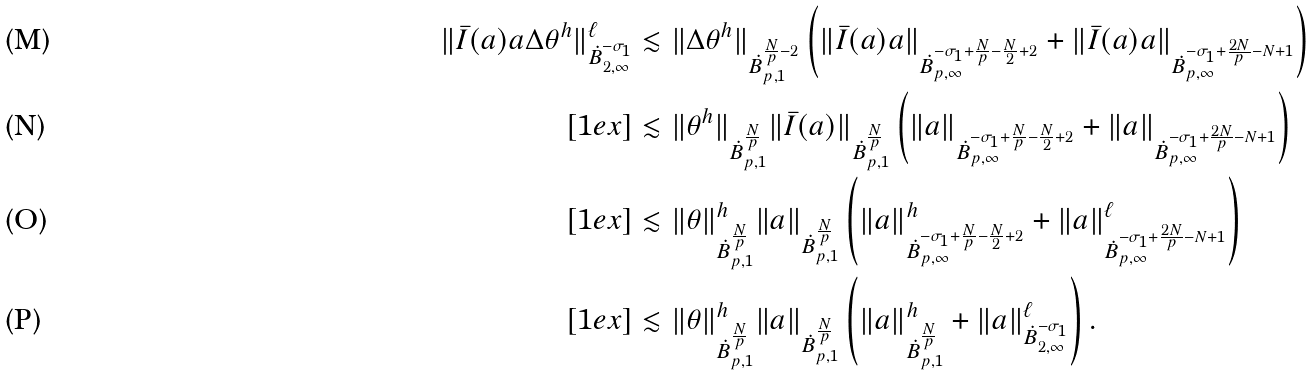<formula> <loc_0><loc_0><loc_500><loc_500>\| \bar { I } ( a ) a \Delta \theta ^ { h } \| _ { \dot { B } _ { 2 , \infty } ^ { - \sigma _ { 1 } } } ^ { \ell } & \lesssim \| \Delta \theta ^ { h } \| _ { \dot { B } _ { p , 1 } ^ { \frac { N } { p } - 2 } } \left ( \| \bar { I } ( a ) a \| _ { \dot { B } _ { p , \infty } ^ { - \sigma _ { 1 } + \frac { N } { p } - \frac { N } { 2 } + 2 } } + \| \bar { I } ( a ) a \| _ { \dot { B } _ { p , \infty } ^ { - \sigma _ { 1 } + \frac { 2 N } { p } - N + 1 } } \right ) \\ [ 1 e x ] & \lesssim \| \theta ^ { h } \| _ { \dot { B } _ { p , 1 } ^ { \frac { N } { p } } } \| \bar { I } ( a ) \| _ { \dot { B } _ { p , 1 } ^ { \frac { N } { p } } } \left ( \| a \| _ { \dot { B } _ { p , \infty } ^ { - \sigma _ { 1 } + \frac { N } { p } - \frac { N } { 2 } + 2 } } + \| a \| _ { \dot { B } _ { p , \infty } ^ { - \sigma _ { 1 } + \frac { 2 N } { p } - N + 1 } } \right ) \\ [ 1 e x ] & \lesssim \| \theta \| _ { \dot { B } _ { p , 1 } ^ { \frac { N } { p } } } ^ { h } \| a \| _ { \dot { B } _ { p , 1 } ^ { \frac { N } { p } } } \left ( \| a \| _ { \dot { B } _ { p , \infty } ^ { - \sigma _ { 1 } + \frac { N } { p } - \frac { N } { 2 } + 2 } } ^ { h } + \| a \| _ { \dot { B } _ { p , \infty } ^ { - \sigma _ { 1 } + \frac { 2 N } { p } - N + 1 } } ^ { \ell } \right ) \\ [ 1 e x ] & \lesssim \| \theta \| _ { \dot { B } _ { p , 1 } ^ { \frac { N } { p } } } ^ { h } \| a \| _ { \dot { B } _ { p , 1 } ^ { \frac { N } { p } } } \left ( \| a \| _ { \dot { B } _ { p , 1 } ^ { \frac { N } { p } } } ^ { h } + \| a \| _ { \dot { B } _ { 2 , \infty } ^ { - \sigma _ { 1 } } } ^ { \ell } \right ) .</formula> 